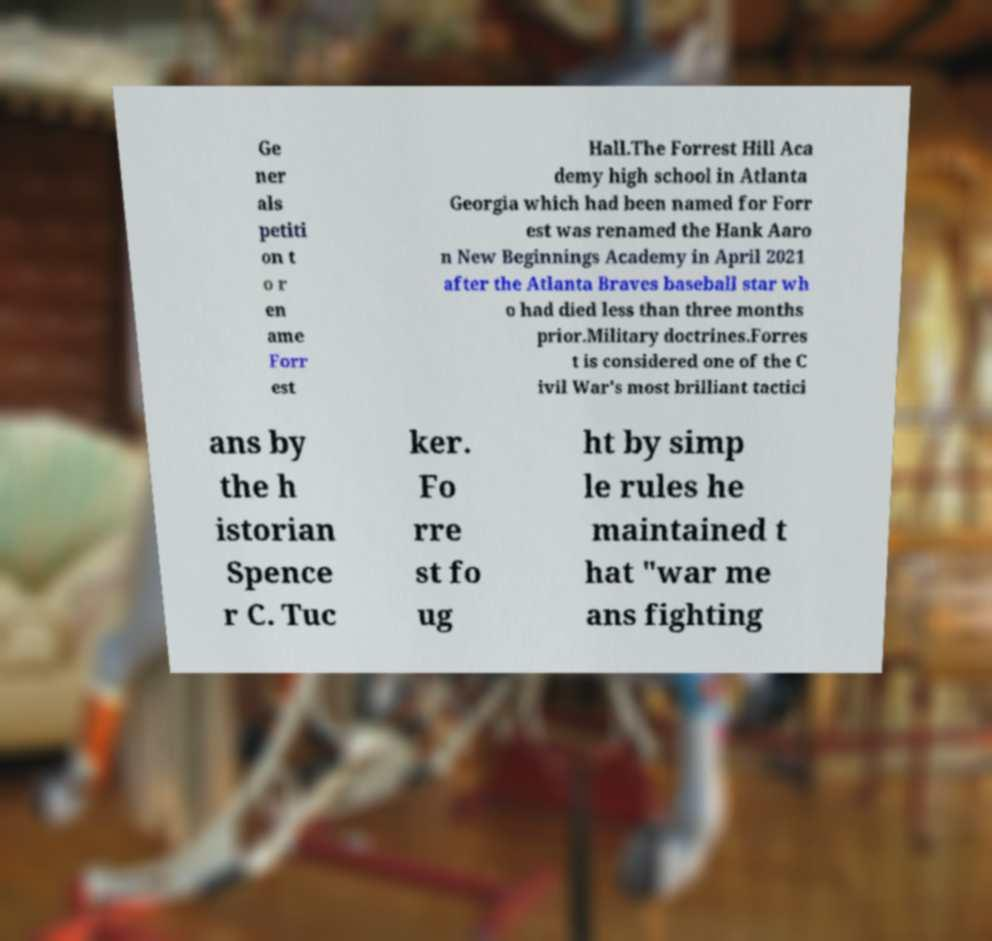Could you assist in decoding the text presented in this image and type it out clearly? Ge ner als petiti on t o r en ame Forr est Hall.The Forrest Hill Aca demy high school in Atlanta Georgia which had been named for Forr est was renamed the Hank Aaro n New Beginnings Academy in April 2021 after the Atlanta Braves baseball star wh o had died less than three months prior.Military doctrines.Forres t is considered one of the C ivil War's most brilliant tactici ans by the h istorian Spence r C. Tuc ker. Fo rre st fo ug ht by simp le rules he maintained t hat "war me ans fighting 